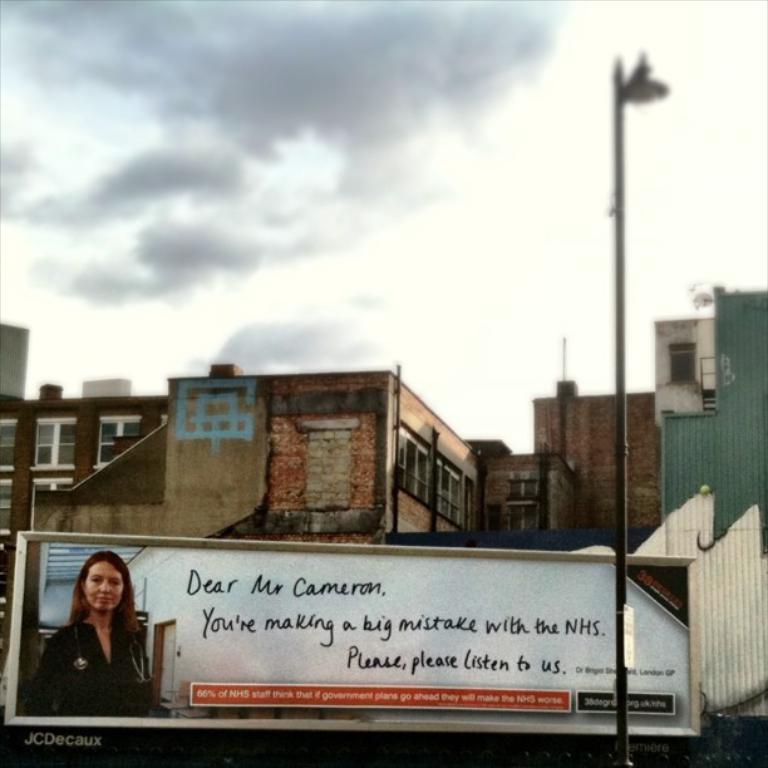Could you give a brief overview of what you see in this image? In this image in the front there is a board with some text and image on it and there is a pole. In the background there are buildings and the sky is cloudy. 